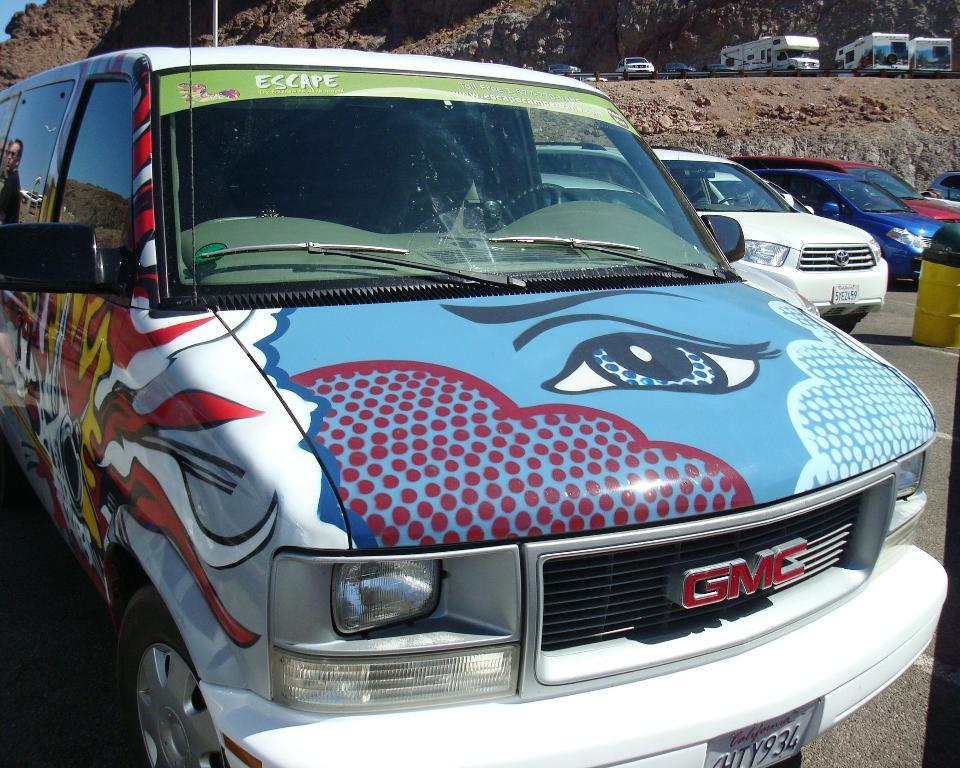<image>
Offer a succinct explanation of the picture presented. A GMC van is painted with an eye on the hood. 